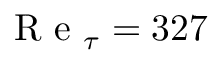Convert formula to latex. <formula><loc_0><loc_0><loc_500><loc_500>R e _ { \tau } = 3 2 7</formula> 